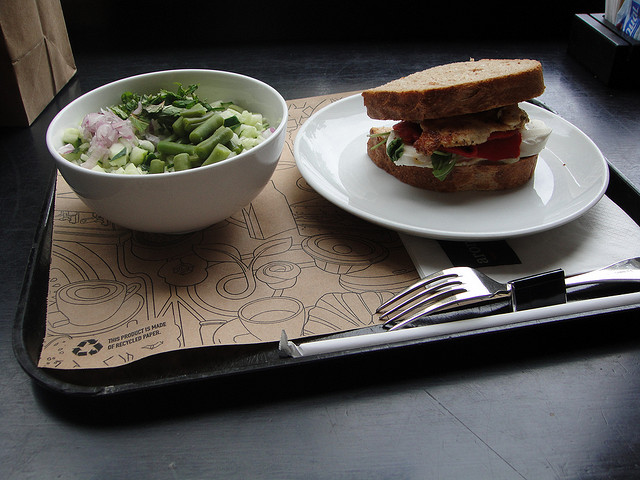<image>What animal is depicted on the placemat? There is no animal depicted on the placemat. What animal is depicted on the placemat? It is ambiguous what animal is depicted on the placemat. It can be seen as monkey, frog, pig or nothing. 